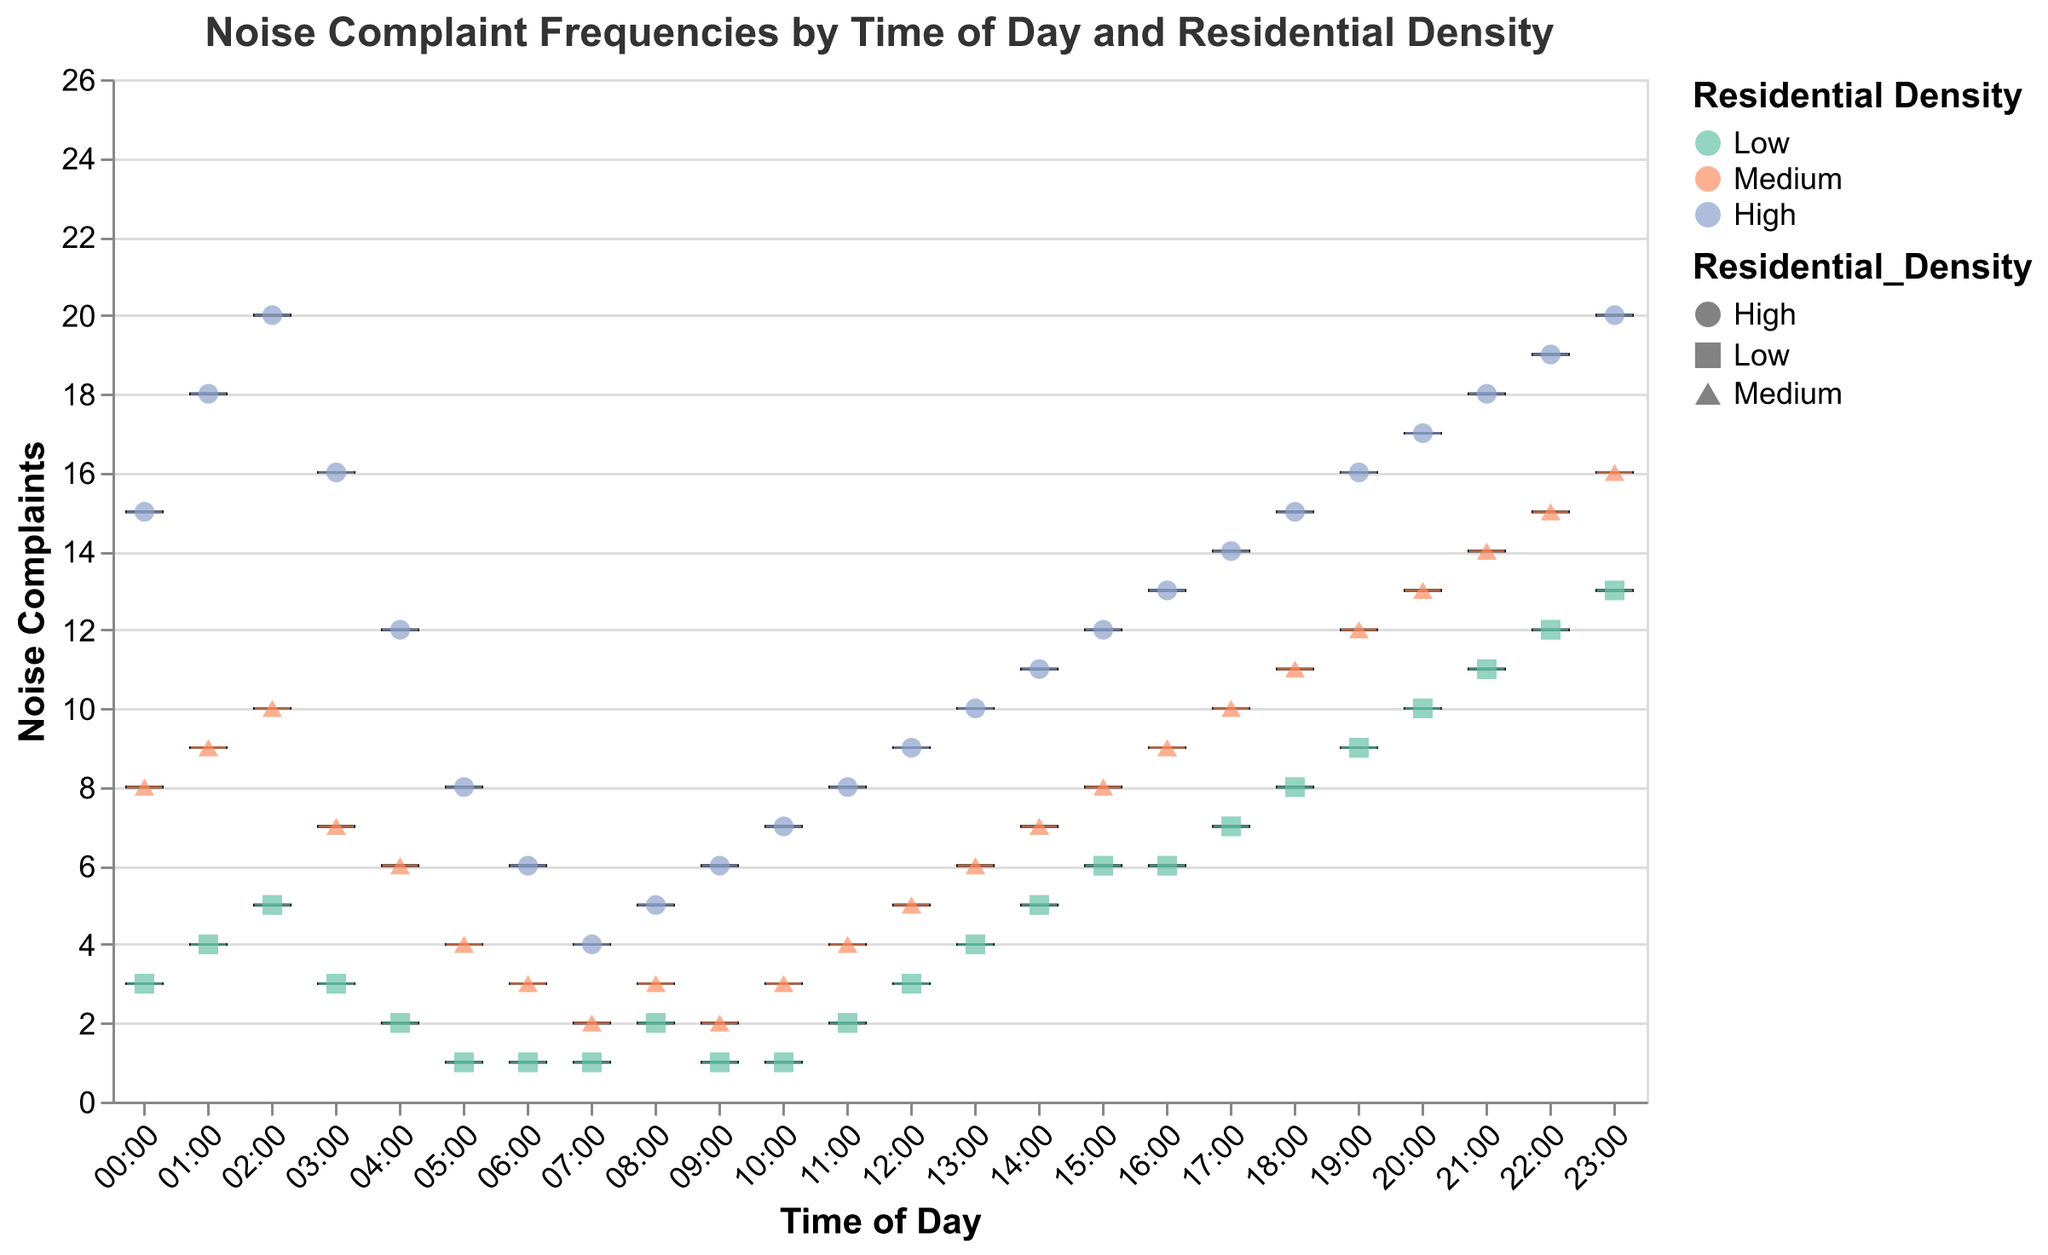What is the title of the figure? The title is shown at the top of the figure. It reads "Noise Complaint Frequencies by Time of Day and Residential Density".
Answer: Noise Complaint Frequencies by Time of Day and Residential Density How many different categories of residential density are used in the plot? There are three color-coded categories visible in the legend: Low, Medium, and High.
Answer: Three What time of day has the highest number of noise complaints for high residential density? Look at the scatter points and box plots for "High" density and identify the maximum y-value. The highest point is at 23:00 with 20 complaints.
Answer: 23:00 What is the range of noise complaints in medium-density areas at 15:00? Check the box plot for "Medium" density at 15:00. The box plot extends from the very minimum to the very maximum values, which are 8 and 8 respectively. Hence, the range is from 8 to 8.
Answer: 8 to 8 Which residential density shows the biggest spread in noise complaints at 21:00? Compare the IQR (Interquartile Range) of the box plots at 21:00. "Medium" has a wider box plot than "Low" and "High," indicating a bigger spread.
Answer: Medium What is the minimum number of noise complaints recorded at 04:00? Look at all points and box plot values at 04:00, and identify the minimum value among them. The minimum value is 2 in the Low density category.
Answer: 2 Between 00:00 and 23:00, which residential density category has the most consistent (least variable) number of noise complaints? Consider the box plots and the consistent range of the values in different density categories. "Low" density consistently shows smaller ranges and values across different times of the day.
Answer: Low Is there a significant jump in noise complaints at a certain time of day for high-density areas? If so, at what time? Observe the scatter points and box plots. There is a notable increase in noise complaints from 18:00 (15 complaints) to 19:00 (16 complaints), and onwards, indicating a trend starting at around the evening.
Answer: Around 19:00 At which time of day do all three residential density categories have the same number of noise complaints? Identify times when the scatter points align horizontally for all three density categories. At "06:00", all categories have equivalent complaints: 6 for High, 3 for Medium, and 1 for Low.
Answer: Never 